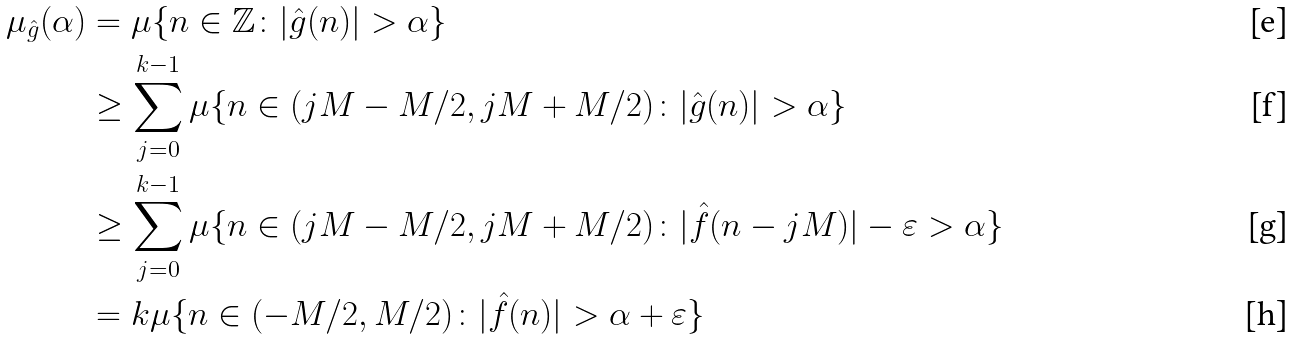Convert formula to latex. <formula><loc_0><loc_0><loc_500><loc_500>\mu _ { \hat { g } } ( \alpha ) & = \mu \{ n \in \mathbb { Z } \colon | \hat { g } ( n ) | > \alpha \} \\ & \geq \sum _ { j = 0 } ^ { k - 1 } \mu \{ n \in ( j M - M / 2 , j M + M / 2 ) \colon | \hat { g } ( n ) | > \alpha \} \\ & \geq \sum _ { j = 0 } ^ { k - 1 } \mu \{ n \in ( j M - M / 2 , j M + M / 2 ) \colon | \hat { f } ( n - j M ) | - \varepsilon > \alpha \} \\ & = k \mu \{ n \in ( - M / 2 , M / 2 ) \colon | \hat { f } ( n ) | > \alpha + \varepsilon \}</formula> 